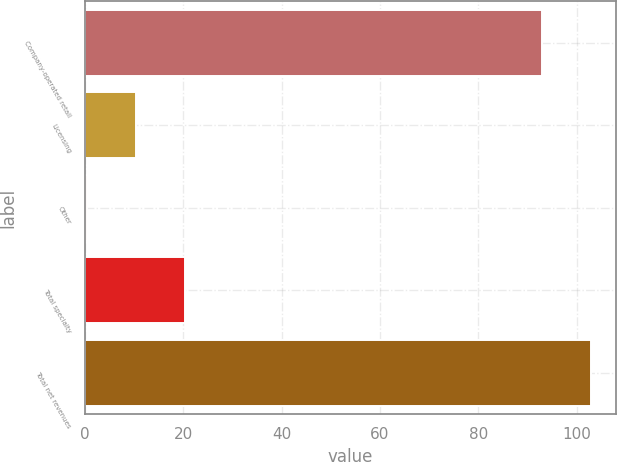Convert chart to OTSL. <chart><loc_0><loc_0><loc_500><loc_500><bar_chart><fcel>Company-operated retail<fcel>Licensing<fcel>Other<fcel>Total specialty<fcel>Total net revenues<nl><fcel>92.9<fcel>10.36<fcel>0.4<fcel>20.32<fcel>102.86<nl></chart> 